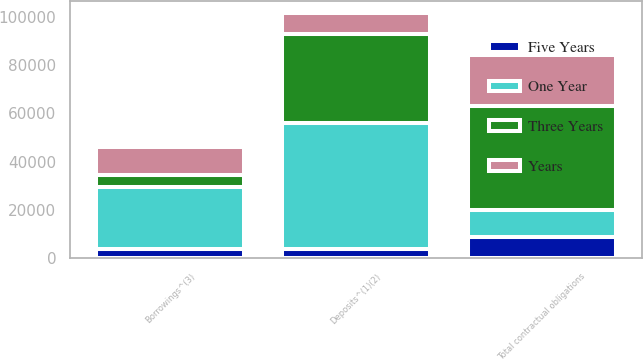Convert chart to OTSL. <chart><loc_0><loc_0><loc_500><loc_500><stacked_bar_chart><ecel><fcel>Deposits^(1)(2)<fcel>Borrowings^(3)<fcel>Total contractual obligations<nl><fcel>One Year<fcel>51992<fcel>25443<fcel>11256<nl><fcel>Three Years<fcel>36984<fcel>5100<fcel>43115<nl><fcel>Years<fcel>8390<fcel>11256<fcel>20900<nl><fcel>Five Years<fcel>4005<fcel>4121<fcel>8743<nl></chart> 